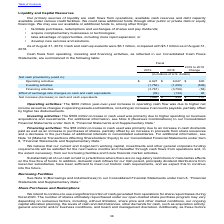According to Accenture Plc's financial document, What is the company's increase in income from operating activities between 2018 and 2019?  According to the financial document, $600 (in millions). The relevant text states: "Operating activities $ 6,627 $ 6,027 $ 600..." Also, What is the company's cash and cash equivalents as at 31 August 2019? As of August 31, 2019, Cash and cash equivalents were $6.1 billion. The document states: "As of August 31, 2019, Cash and cash equivalents were $6.1 billion, compared with $5.1 billion as of August 31,..." Also, What is the increase in cash flow from investing activities between 2018 and 2019? According to the financial document, $506 (in millions). The relevant text states: "Investing activities: The $506 million increase in cash used was primarily due to higher spending on business..." Also, can you calculate: What is the total cash flow in operating activity  in 2018 and 2019? Based on the calculation: $6,627 + $6,027 , the result is 12654. This is based on the information: "Operating activities $ 6,627 $ 6,027 $ 600 Operating activities $ 6,627 $ 6,027 $ 600..." The key data points involved are: 6,027, 6,627. Also, can you calculate: What is the total cashflow from investing activities in both 2018 and 2019? Based on the calculation: - 1,756 + (-1,250) , the result is -3006 (in millions). This is based on the information: "Investing activities (1,756) (1,250) (506) Investing activities (1,756) (1,250) (506)..." The key data points involved are: 1,250, 1,756. Also, can you calculate: What is the total effect of exchange rate changes on cash and cash equivalents in both 2018 and 2019? Based on the calculation: -39+(-134) , the result is -173 (in millions). This is based on the information: "change rate changes on cash and cash equivalents (39) (134) 95 e rate changes on cash and cash equivalents (39) (134) 95..." The key data points involved are: 134, 39. 